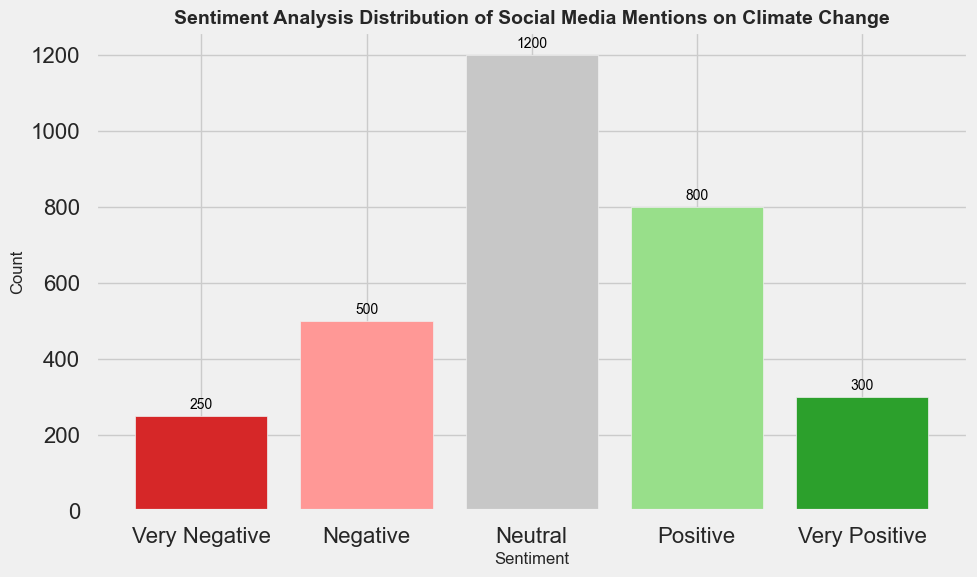Which sentiment has the highest count? The bar with the highest length indicates the sentiment with the highest count. The "Neutral" sentiment bar is the tallest.
Answer: Neutral How many total mentions are there for positive sentiments ("Positive" and "Very Positive")? Combine the counts for "Positive" (800) and "Very Positive" (300): 800 + 300 = 1100.
Answer: 1100 Which sentiment has the fewest mentions? The shortest bar represents the sentiment with the fewest mentions. The "Very Negative" sentiment bar is the shortest.
Answer: Very Negative Are there more negative (Negative + Very Negative) or positive (Positive + Very Positive) mentions? Calculate the total for both: Negative: 500 + 250 = 750; Positive: 800 + 300 = 1100. Compare the totals: 750 < 1100.
Answer: Positive What's the difference in count between "Neutral" and "Very Positive" mentions? Subtract the count of "Very Positive" (300) from "Neutral" (1200): 1200 - 300 = 900.
Answer: 900 Which sentiment is represented by the red-colored bar? The red-colored bar corresponds to "Very Negative."
Answer: Very Negative Is the count for "Positive" mentions greater than the count for any negative mentions? Compare "Positive" (800) with "Negative" (500) and "Very Negative" (250): 800 > 500 and 800 > 250.
Answer: Yes What is the sum of counts for the two sentiment categories with the lowest mentions? Add counts for "Very Negative" (250) and "Very Positive" (300): 250 + 300 = 550.
Answer: 550 Which sentiment has a bar height that is approximately halfway between the heights of the "Negative" and "Very Positive" bars? "Negative" is 500 and "Very Positive" is 300. The halfway count is (500 + 300) / 2 = 400. The closest sentiment is "Very Negative" at 250, but it is not quite halfway.
Answer: None What's the count difference between the most and least frequent sentiment? Subtract the count of the least frequent ("Very Negative" 250) from the most frequent ("Neutral" 1200): 1200 - 250 = 950.
Answer: 950 